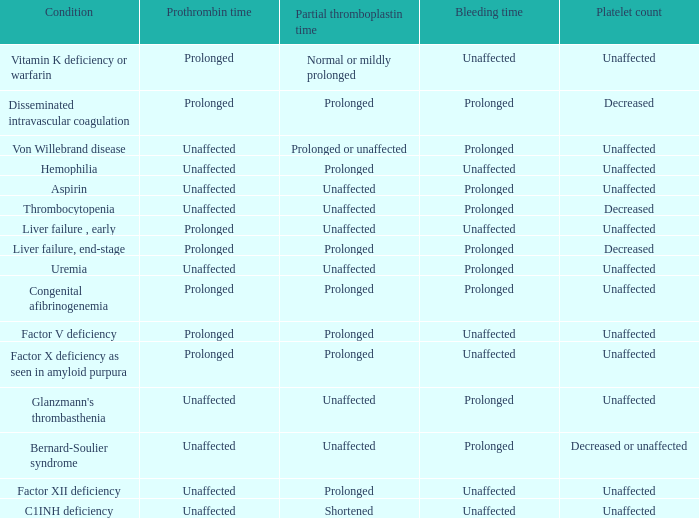When factor x deficiency is present in amyloid purpura, how long does the bleeding time last? Unaffected. 